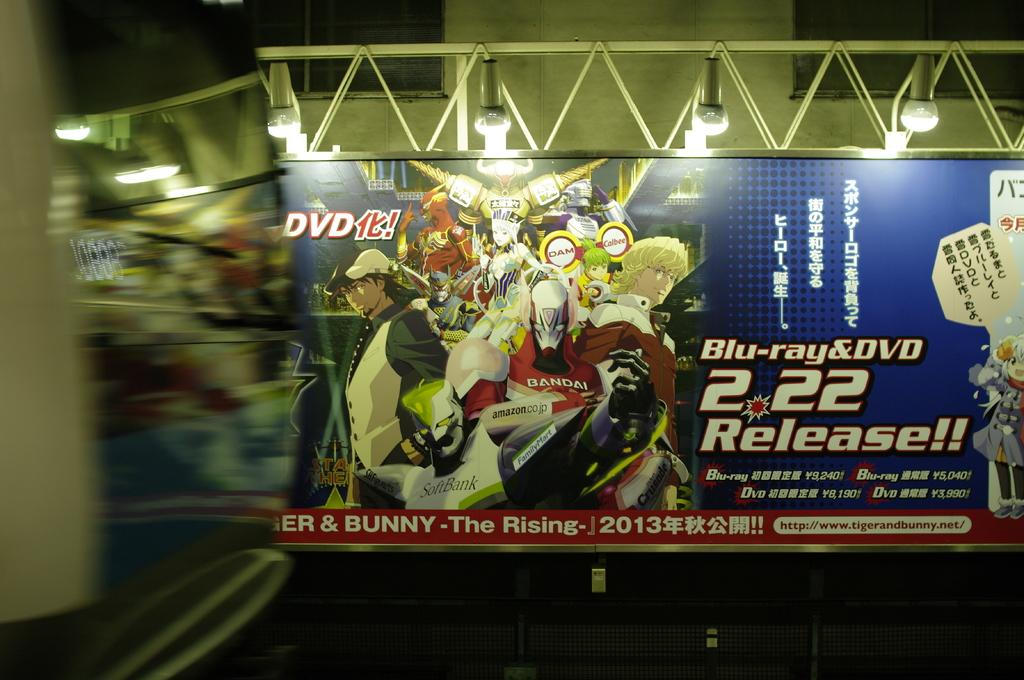<image>
Offer a succinct explanation of the picture presented. Blu ray and dvd release of the rising in 2013 